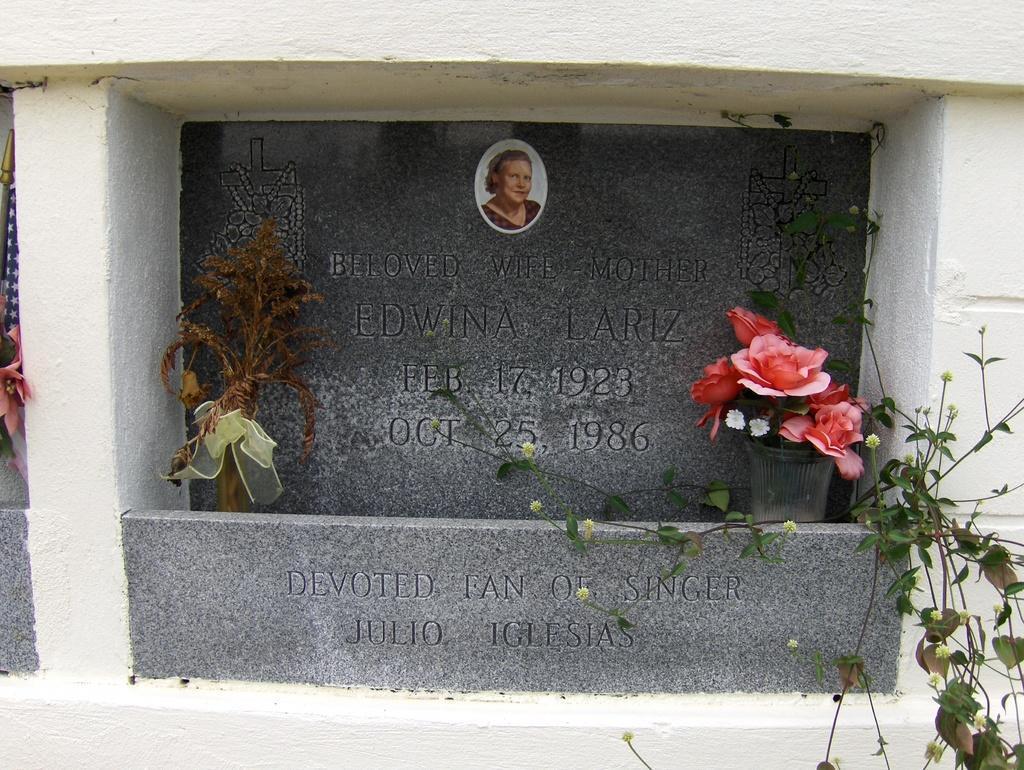Can you describe this image briefly? In this picture we can observe a gravestone of a person. There is a bouquet and flowers placed on either sides of his gravestone. This gravestone is in grey color. We can observe a wall and a plant hire. 